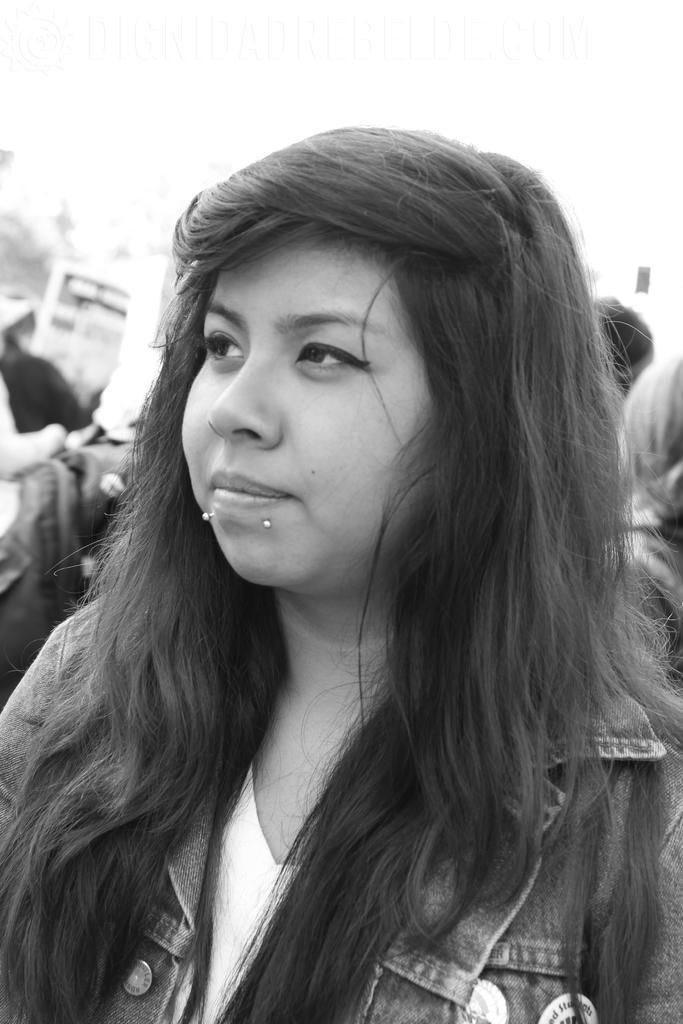Describe this image in one or two sentences. This image is a black and white image. This image is taken outdoors. In the background there are few people. In the middle of the image there is a girl. She has worn a jacket. 